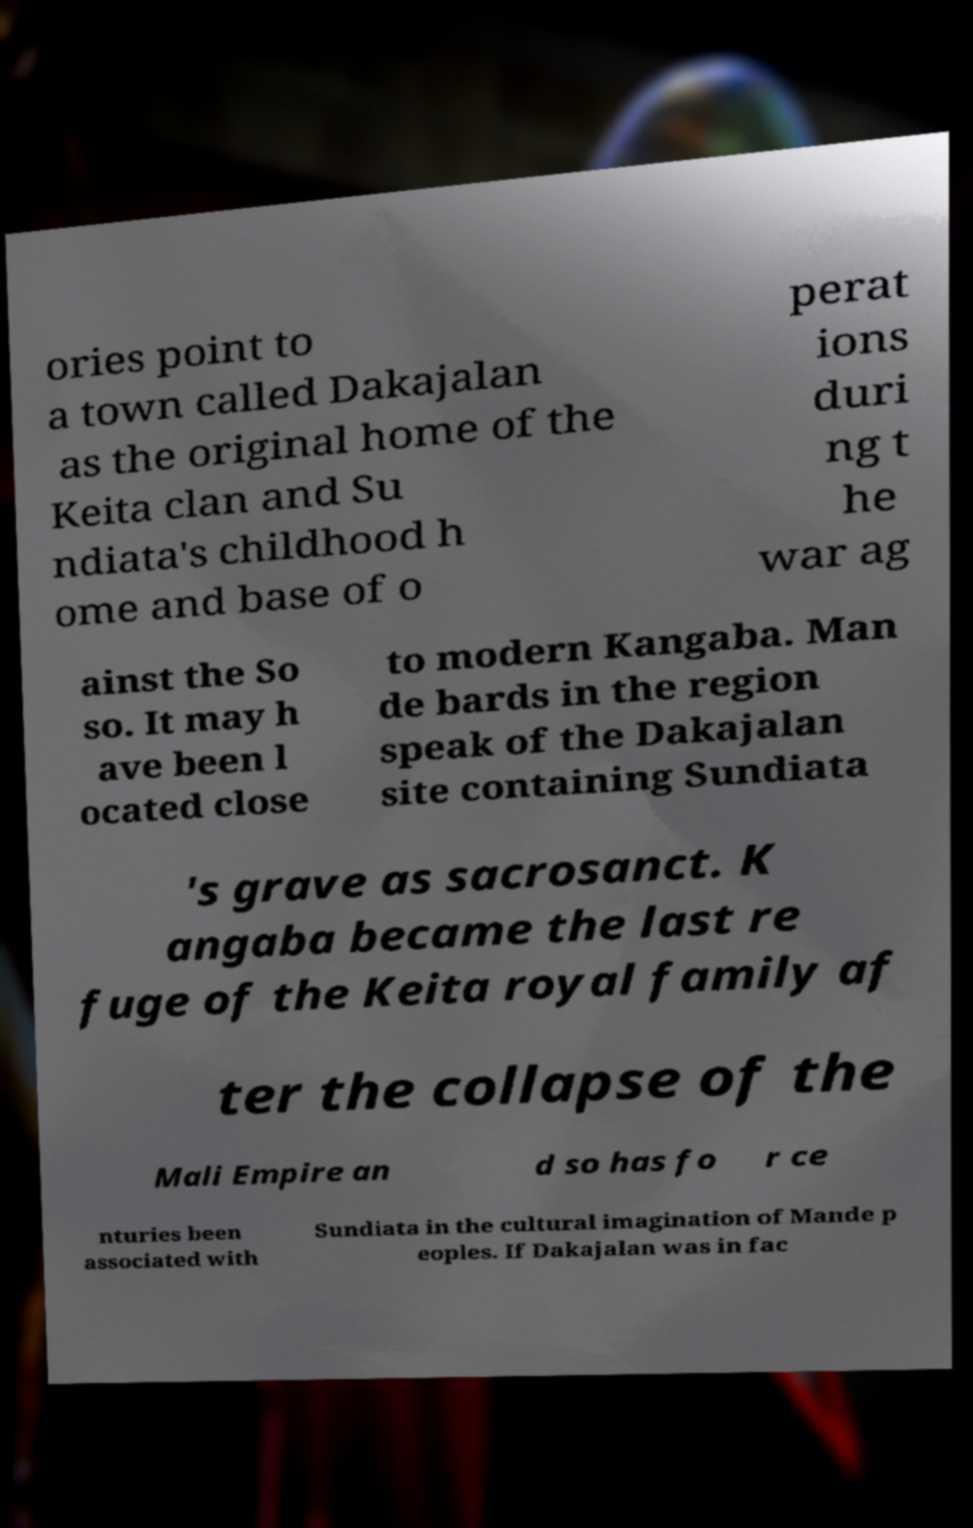Can you accurately transcribe the text from the provided image for me? ories point to a town called Dakajalan as the original home of the Keita clan and Su ndiata's childhood h ome and base of o perat ions duri ng t he war ag ainst the So so. It may h ave been l ocated close to modern Kangaba. Man de bards in the region speak of the Dakajalan site containing Sundiata 's grave as sacrosanct. K angaba became the last re fuge of the Keita royal family af ter the collapse of the Mali Empire an d so has fo r ce nturies been associated with Sundiata in the cultural imagination of Mande p eoples. If Dakajalan was in fac 